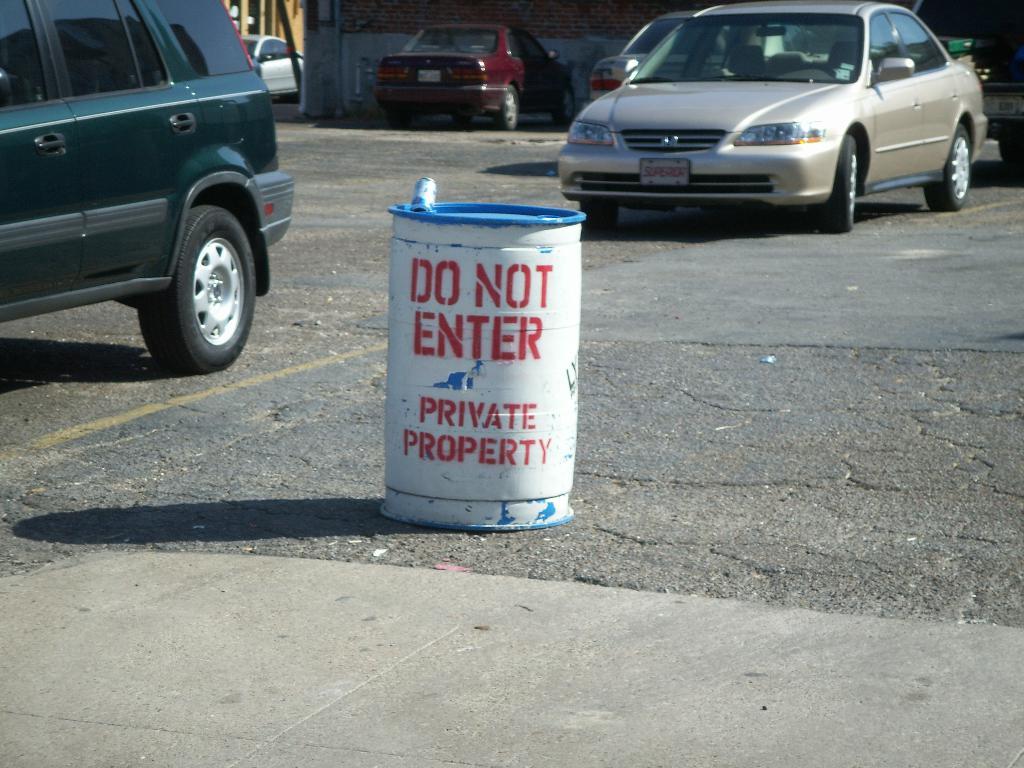What make of car is shown?
Offer a terse response. Honda. 